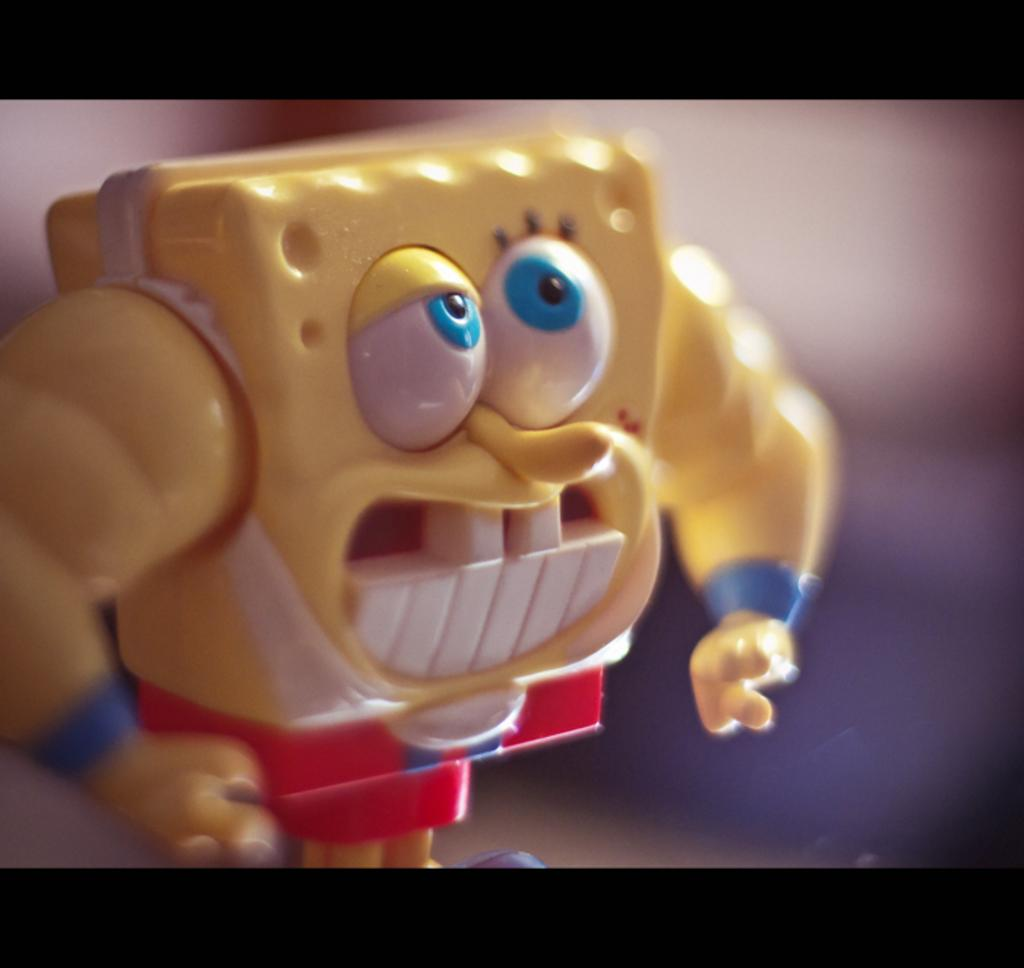What object can be seen in the image? There is a toy in the image. How many kittens are playing with the toy in the image? There are no kittens present in the image; it only features a toy. What type of waste is visible in the image? There is no waste visible in the image; it only features a toy. 